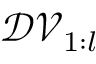<formula> <loc_0><loc_0><loc_500><loc_500>\mathcal { D V } _ { 1 \colon l }</formula> 